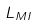Convert formula to latex. <formula><loc_0><loc_0><loc_500><loc_500>L _ { M I }</formula> 